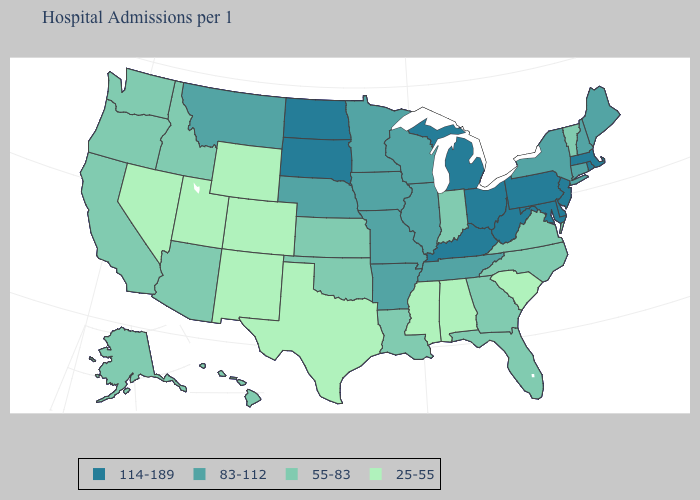Which states have the highest value in the USA?
Write a very short answer. Delaware, Kentucky, Maryland, Massachusetts, Michigan, New Jersey, North Dakota, Ohio, Pennsylvania, Rhode Island, South Dakota, West Virginia. What is the value of Minnesota?
Give a very brief answer. 83-112. Name the states that have a value in the range 55-83?
Give a very brief answer. Alaska, Arizona, California, Florida, Georgia, Hawaii, Idaho, Indiana, Kansas, Louisiana, North Carolina, Oklahoma, Oregon, Vermont, Virginia, Washington. Name the states that have a value in the range 114-189?
Concise answer only. Delaware, Kentucky, Maryland, Massachusetts, Michigan, New Jersey, North Dakota, Ohio, Pennsylvania, Rhode Island, South Dakota, West Virginia. What is the value of Texas?
Be succinct. 25-55. What is the highest value in states that border Alabama?
Be succinct. 83-112. Does Florida have a higher value than Wyoming?
Concise answer only. Yes. Does Oregon have the highest value in the USA?
Quick response, please. No. Which states have the lowest value in the USA?
Answer briefly. Alabama, Colorado, Mississippi, Nevada, New Mexico, South Carolina, Texas, Utah, Wyoming. Does Idaho have a higher value than Alabama?
Give a very brief answer. Yes. Name the states that have a value in the range 25-55?
Short answer required. Alabama, Colorado, Mississippi, Nevada, New Mexico, South Carolina, Texas, Utah, Wyoming. Does Indiana have the lowest value in the USA?
Give a very brief answer. No. Does New York have a higher value than Wisconsin?
Answer briefly. No. Which states have the lowest value in the USA?
Be succinct. Alabama, Colorado, Mississippi, Nevada, New Mexico, South Carolina, Texas, Utah, Wyoming. Among the states that border Pennsylvania , which have the lowest value?
Be succinct. New York. 